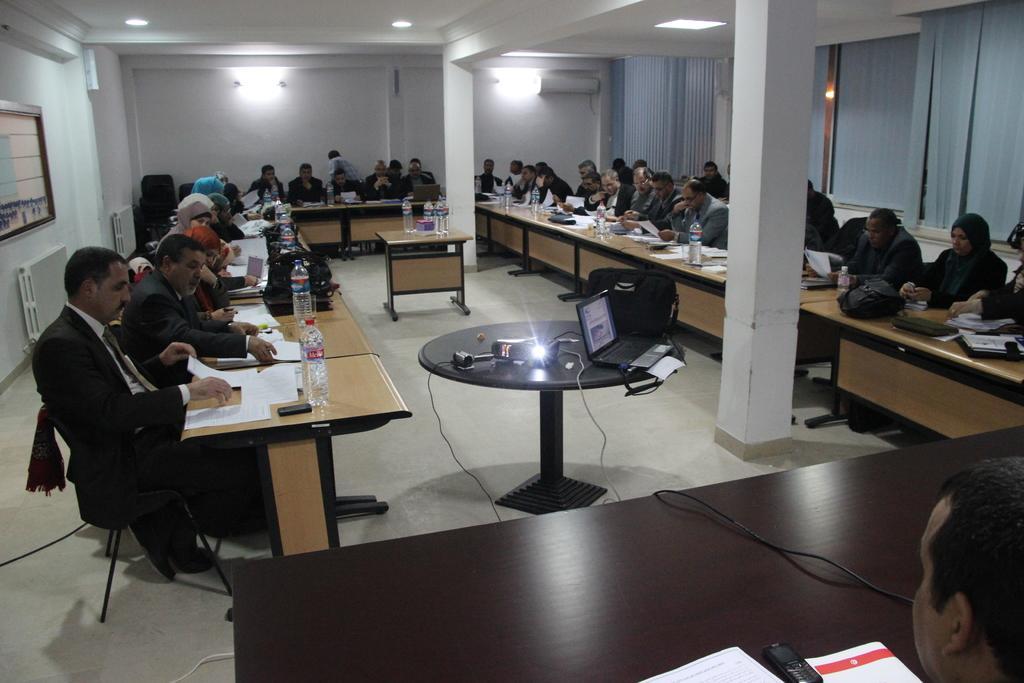How would you summarize this image in a sentence or two? I can see in this image a group of people are sitting on a chair in front of a table. On the table we have few bottles, laptop and other objects on it. I can see there is a white color wall and curtains. 